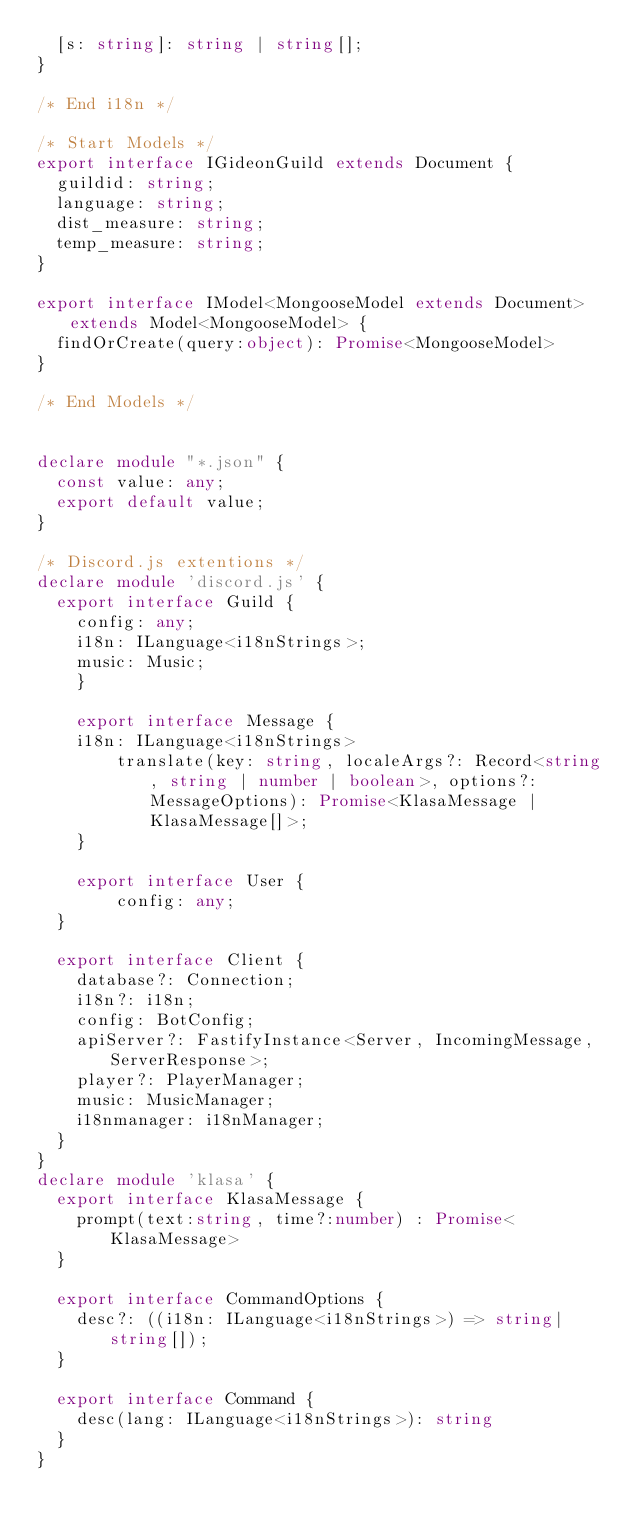Convert code to text. <code><loc_0><loc_0><loc_500><loc_500><_TypeScript_>  [s: string]: string | string[];
}

/* End i18n */

/* Start Models */
export interface IGideonGuild extends Document {
  guildid: string;
  language: string;
  dist_measure: string;
  temp_measure: string;
}

export interface IModel<MongooseModel extends Document> extends Model<MongooseModel> {
  findOrCreate(query:object): Promise<MongooseModel>
}

/* End Models */


declare module "*.json" {
  const value: any;
  export default value;
}

/* Discord.js extentions */
declare module 'discord.js' {
  export interface Guild {
    config: any;
    i18n: ILanguage<i18nStrings>;
    music: Music;
	}

	export interface Message {
    i18n: ILanguage<i18nStrings>
		translate(key: string, localeArgs?: Record<string, string | number | boolean>, options?: MessageOptions): Promise<KlasaMessage | KlasaMessage[]>;
	}

	export interface User {
		config: any;
  }
  
  export interface Client {
    database?: Connection;
    i18n?: i18n;
    config: BotConfig;
    apiServer?: FastifyInstance<Server, IncomingMessage, ServerResponse>;
    player?: PlayerManager;
    music: MusicManager;
    i18nmanager: i18nManager;
  }
}
declare module 'klasa' {
  export interface KlasaMessage {
    prompt(text:string, time?:number) : Promise<KlasaMessage>
  }

  export interface CommandOptions {
    desc?: ((i18n: ILanguage<i18nStrings>) => string|string[]);
  }

  export interface Command {
    desc(lang: ILanguage<i18nStrings>): string
  }
}</code> 